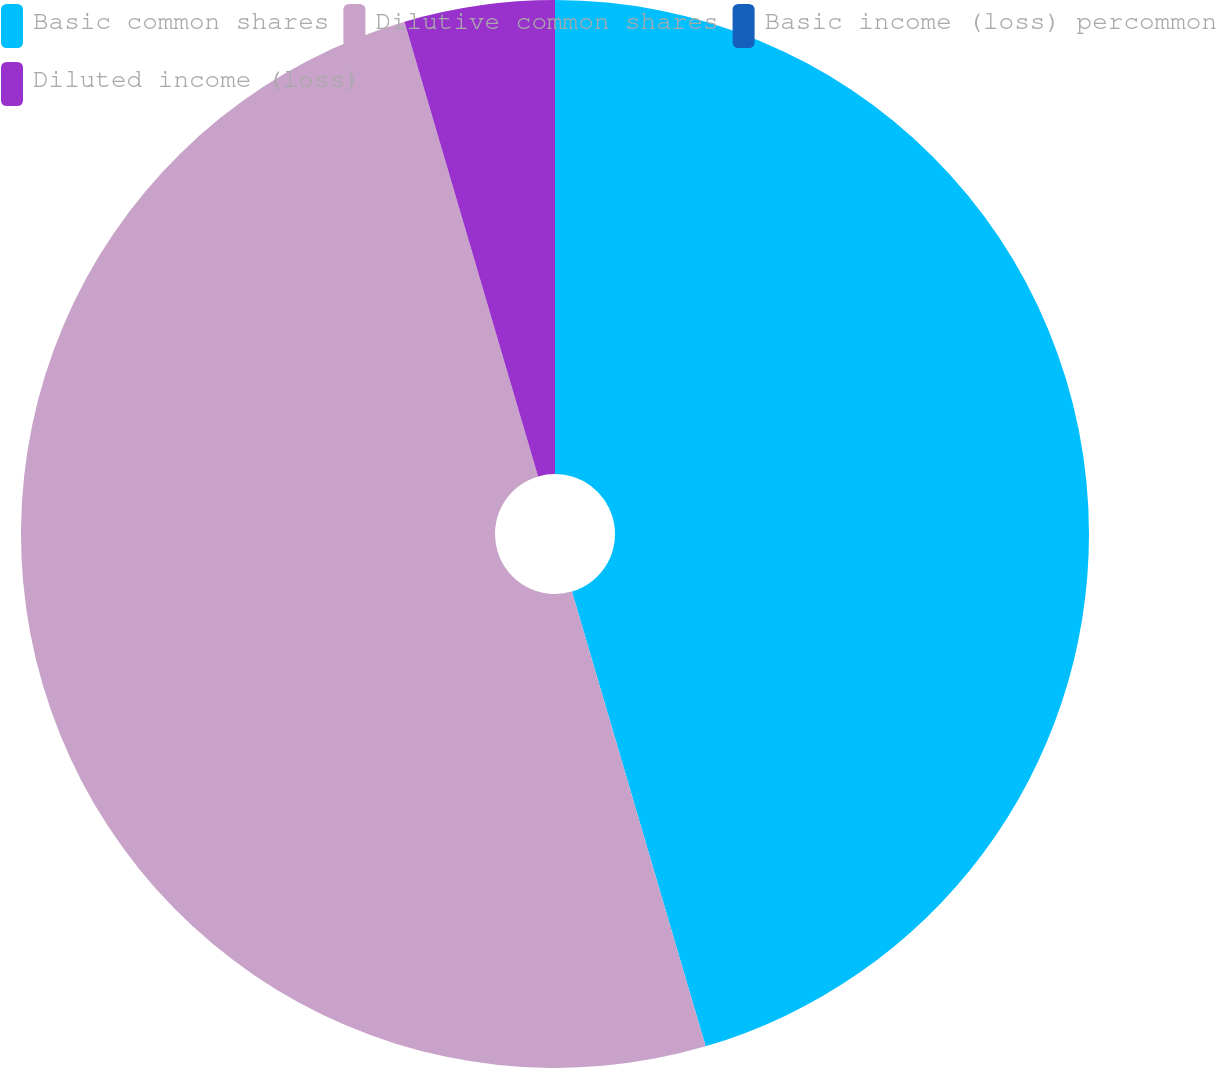<chart> <loc_0><loc_0><loc_500><loc_500><pie_chart><fcel>Basic common shares<fcel>Dilutive common shares<fcel>Basic income (loss) percommon<fcel>Diluted income (loss)<nl><fcel>45.45%<fcel>50.0%<fcel>0.0%<fcel>4.55%<nl></chart> 